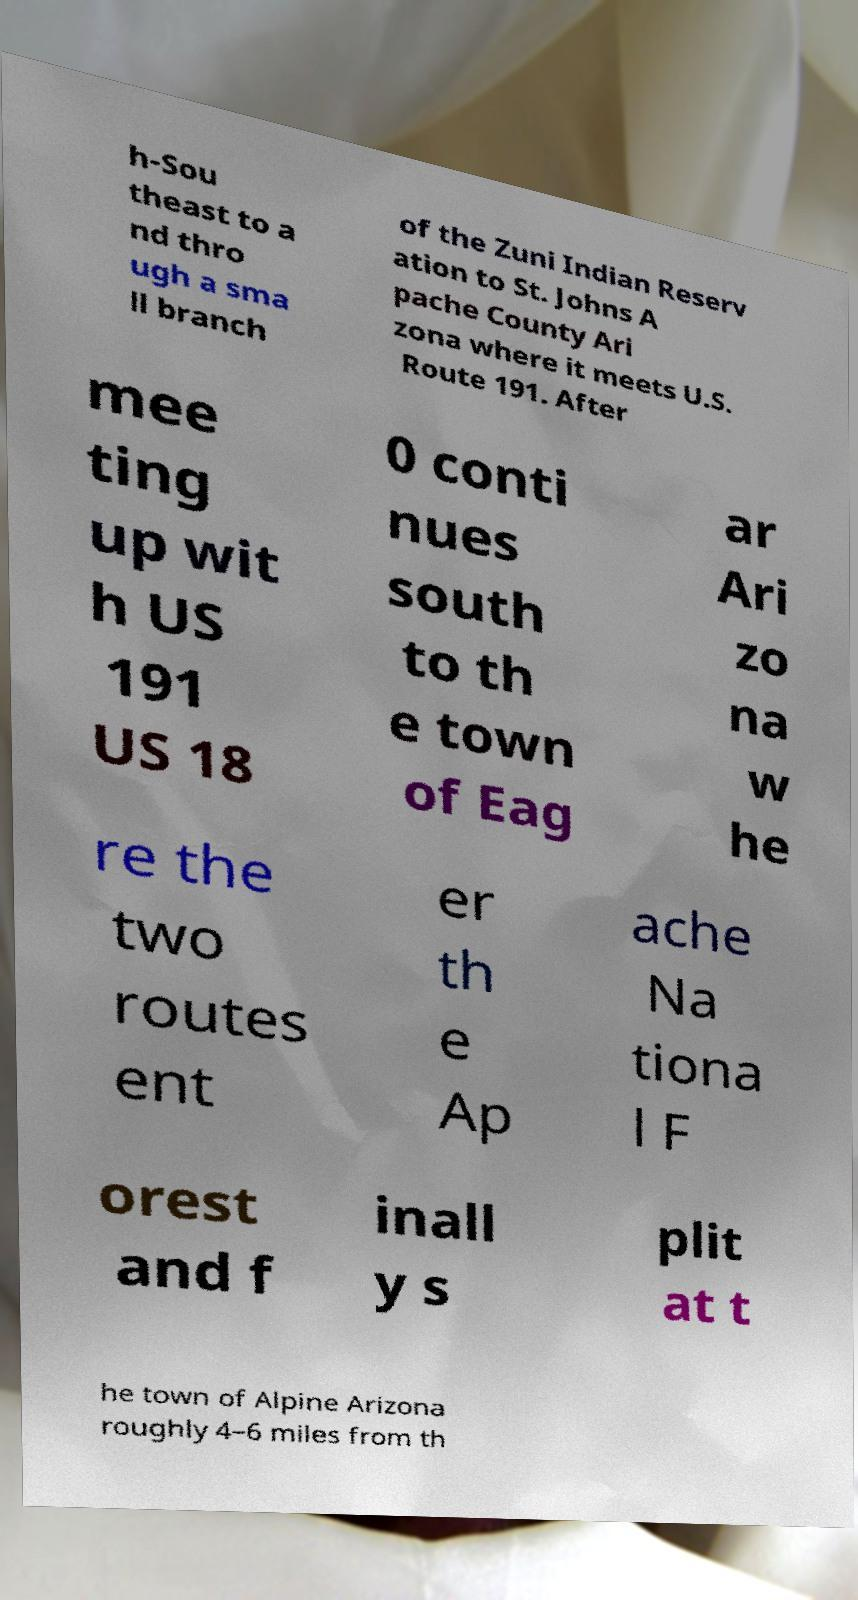What messages or text are displayed in this image? I need them in a readable, typed format. h-Sou theast to a nd thro ugh a sma ll branch of the Zuni Indian Reserv ation to St. Johns A pache County Ari zona where it meets U.S. Route 191. After mee ting up wit h US 191 US 18 0 conti nues south to th e town of Eag ar Ari zo na w he re the two routes ent er th e Ap ache Na tiona l F orest and f inall y s plit at t he town of Alpine Arizona roughly 4–6 miles from th 